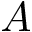Convert formula to latex. <formula><loc_0><loc_0><loc_500><loc_500>A</formula> 